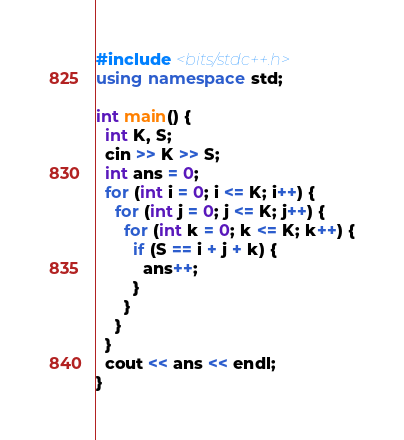Convert code to text. <code><loc_0><loc_0><loc_500><loc_500><_C++_>#include <bits/stdc++.h>
using namespace std;
 
int main() {
  int K, S;
  cin >> K >> S;
  int ans = 0;
  for (int i = 0; i <= K; i++) {
    for (int j = 0; j <= K; j++) {
      for (int k = 0; k <= K; k++) {
        if (S == i + j + k) {
          ans++;
        }
      }
    }
  }
  cout << ans << endl;
}</code> 